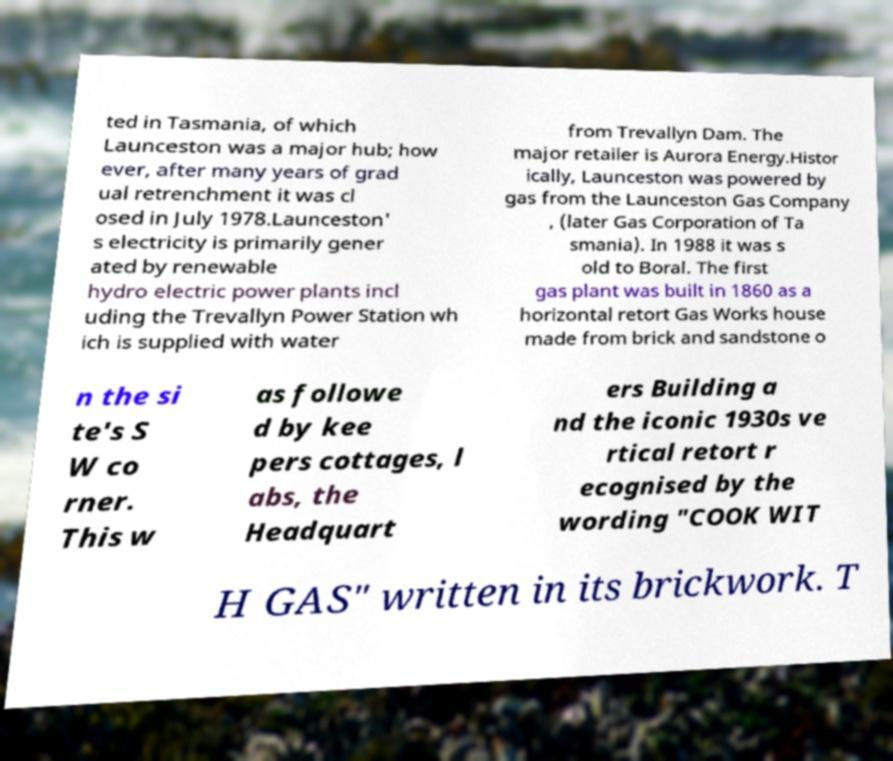I need the written content from this picture converted into text. Can you do that? ted in Tasmania, of which Launceston was a major hub; how ever, after many years of grad ual retrenchment it was cl osed in July 1978.Launceston' s electricity is primarily gener ated by renewable hydro electric power plants incl uding the Trevallyn Power Station wh ich is supplied with water from Trevallyn Dam. The major retailer is Aurora Energy.Histor ically, Launceston was powered by gas from the Launceston Gas Company , (later Gas Corporation of Ta smania). In 1988 it was s old to Boral. The first gas plant was built in 1860 as a horizontal retort Gas Works house made from brick and sandstone o n the si te's S W co rner. This w as followe d by kee pers cottages, l abs, the Headquart ers Building a nd the iconic 1930s ve rtical retort r ecognised by the wording "COOK WIT H GAS" written in its brickwork. T 